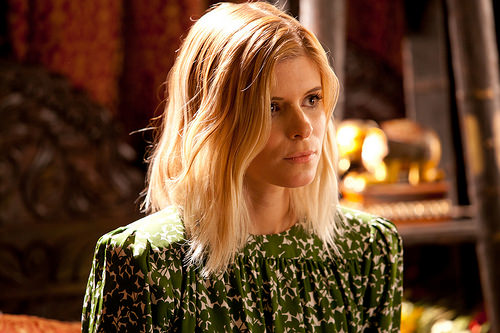<image>
Is the sculpture behind the woman? Yes. From this viewpoint, the sculpture is positioned behind the woman, with the woman partially or fully occluding the sculpture. 